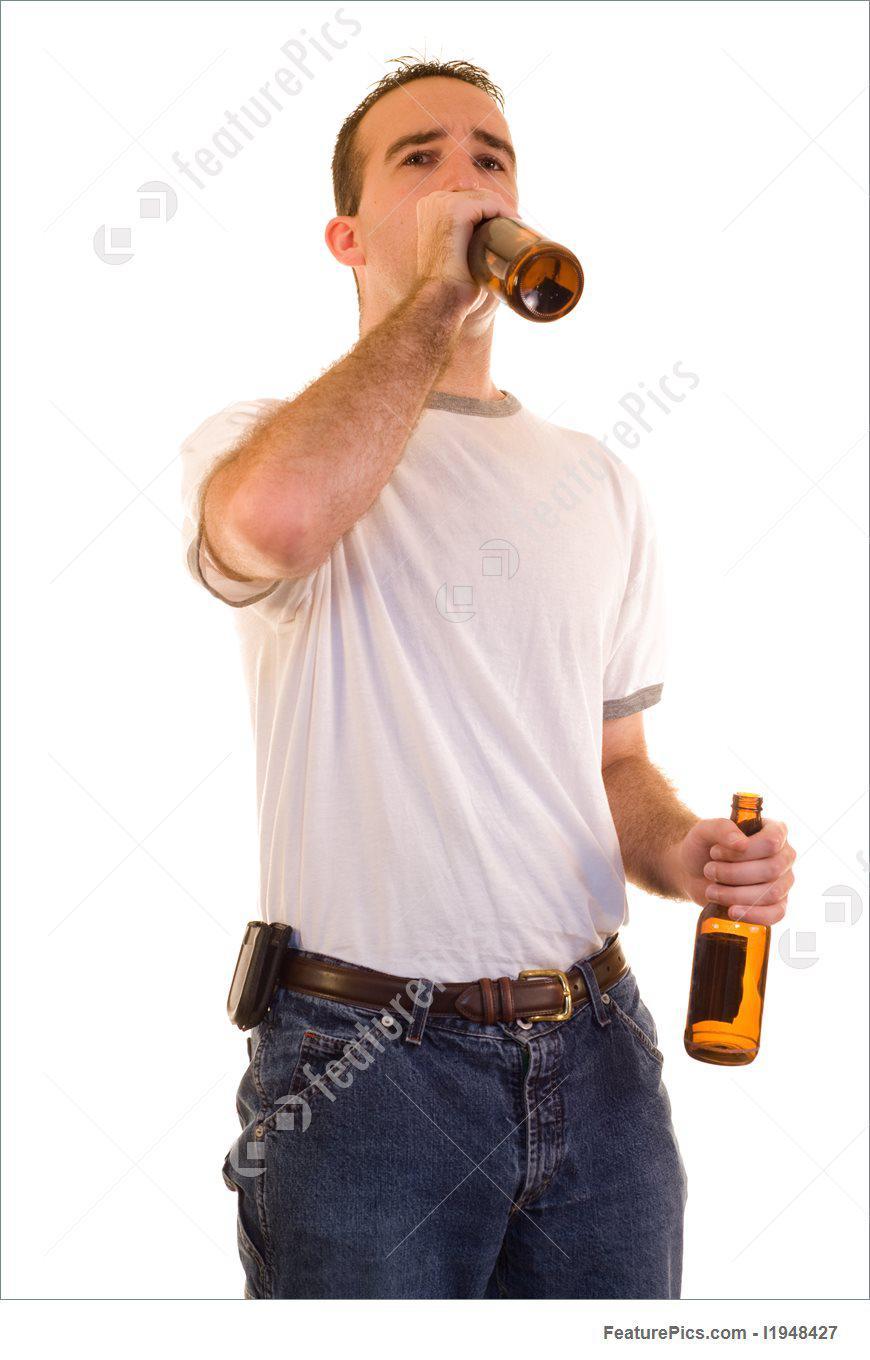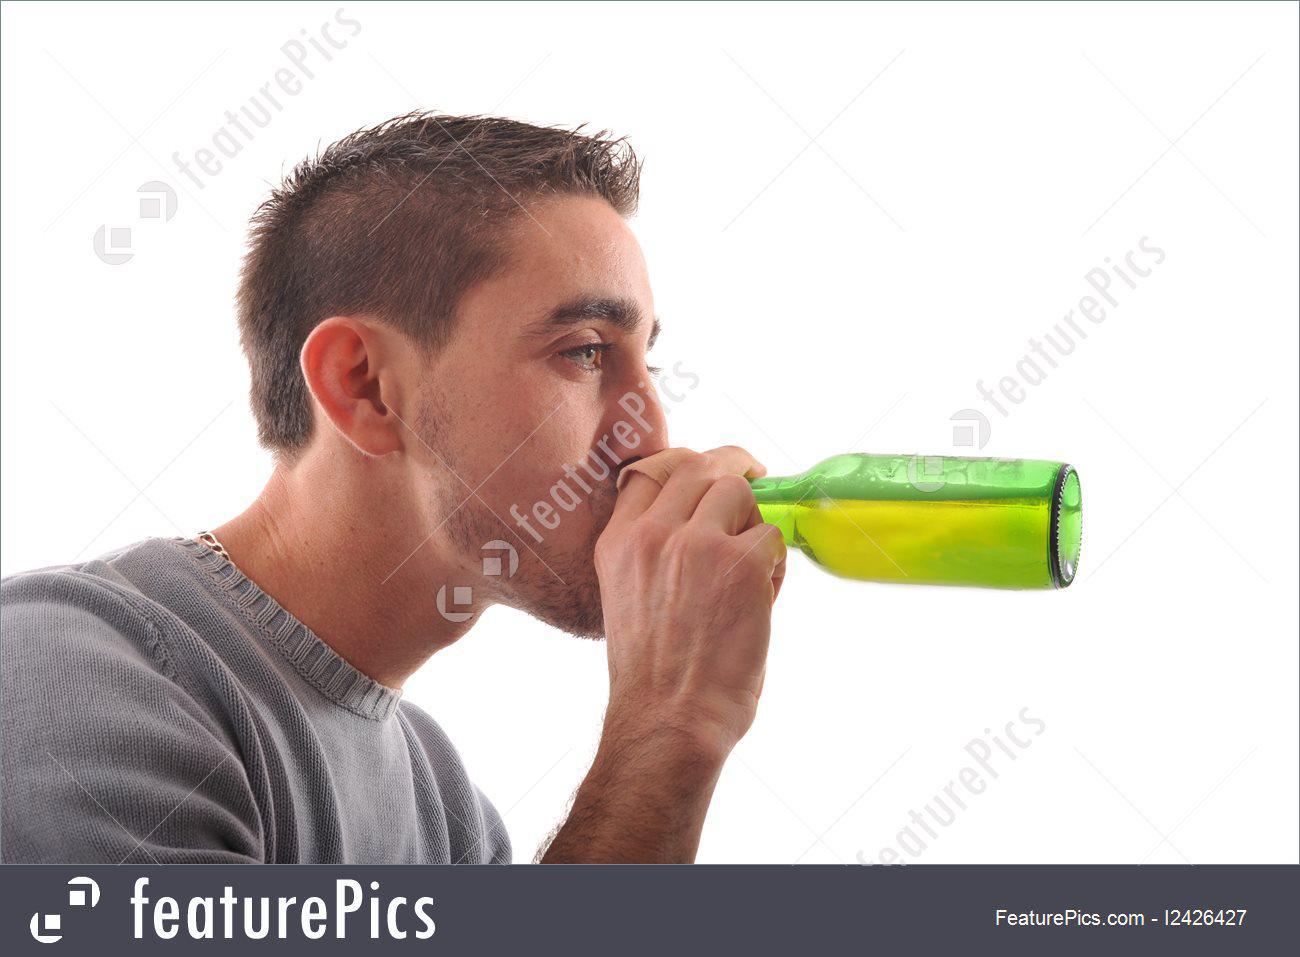The first image is the image on the left, the second image is the image on the right. Given the left and right images, does the statement "There are two guys drinking what appears to be beer." hold true? Answer yes or no. Yes. The first image is the image on the left, the second image is the image on the right. Analyze the images presented: Is the assertion "The left image shows a man leaning his head back to drink from a brown bottle held in one hand, while the other unraised hand holds another brown bottle." valid? Answer yes or no. Yes. 